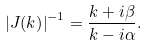<formula> <loc_0><loc_0><loc_500><loc_500>\left | { J ( k ) } \right | ^ { - 1 } = \frac { k + i \beta } { k - i \alpha } .</formula> 